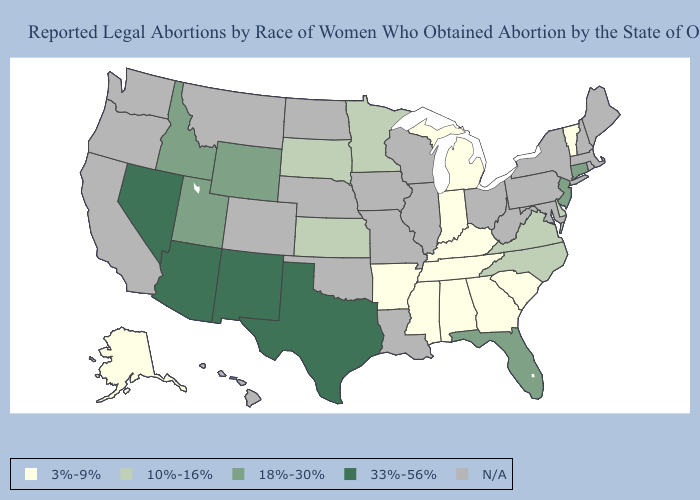Name the states that have a value in the range N/A?
Short answer required. California, Colorado, Hawaii, Illinois, Iowa, Louisiana, Maine, Maryland, Massachusetts, Missouri, Montana, Nebraska, New Hampshire, New York, North Dakota, Ohio, Oklahoma, Oregon, Pennsylvania, Rhode Island, Washington, West Virginia, Wisconsin. Name the states that have a value in the range 10%-16%?
Concise answer only. Delaware, Kansas, Minnesota, North Carolina, South Dakota, Virginia. Name the states that have a value in the range 18%-30%?
Keep it brief. Connecticut, Florida, Idaho, New Jersey, Utah, Wyoming. Which states have the lowest value in the West?
Short answer required. Alaska. What is the highest value in the USA?
Answer briefly. 33%-56%. Among the states that border Idaho , which have the lowest value?
Give a very brief answer. Utah, Wyoming. What is the value of North Carolina?
Quick response, please. 10%-16%. What is the value of New Hampshire?
Write a very short answer. N/A. Name the states that have a value in the range 18%-30%?
Short answer required. Connecticut, Florida, Idaho, New Jersey, Utah, Wyoming. What is the highest value in the Northeast ?
Give a very brief answer. 18%-30%. Does New Jersey have the lowest value in the Northeast?
Keep it brief. No. Name the states that have a value in the range 33%-56%?
Give a very brief answer. Arizona, Nevada, New Mexico, Texas. What is the highest value in the USA?
Write a very short answer. 33%-56%. 